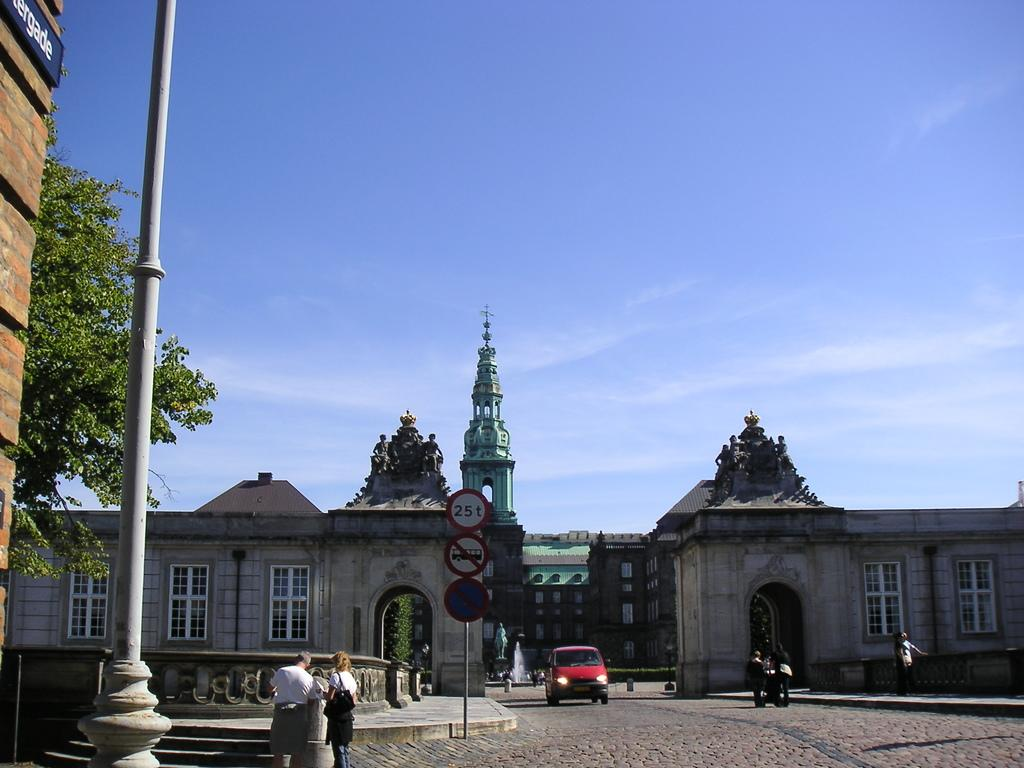What is the main structure visible in the image? There is a pole in the image. What else can be seen on the pole? There are sign boards on the pole. What type of objects are present in the image? There are vehicles, trees, and people in the image. What can be seen in the background of the image? There are buildings in the background of the image. How many balloons are being held by the people in the image? There are no balloons visible in the image; the people are not holding any. What color are the eyes of the trees in the image? Trees do not have eyes, so this question cannot be answered. 